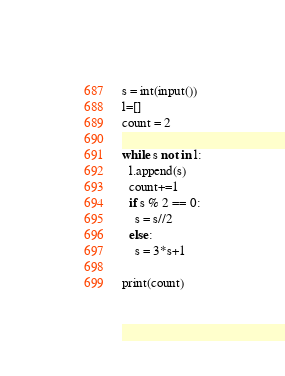Convert code to text. <code><loc_0><loc_0><loc_500><loc_500><_Python_>s = int(input())
l=[]
count = 2

while s not in l:
  l.append(s)
  count+=1
  if s % 2 == 0:
    s = s//2
  else:
    s = 3*s+1

print(count)</code> 